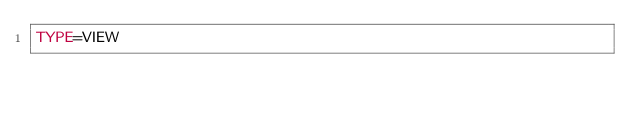Convert code to text. <code><loc_0><loc_0><loc_500><loc_500><_VisualBasic_>TYPE=VIEW</code> 